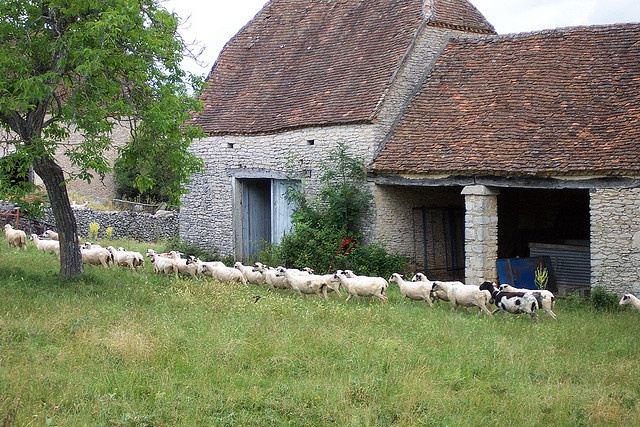Describe the objects in this image and their specific colors. I can see sheep in turquoise, white, gray, olive, and darkgray tones, sheep in turquoise, white, darkgray, tan, and gray tones, sheep in turquoise, black, darkgray, lightgray, and gray tones, sheep in turquoise, white, darkgray, and gray tones, and sheep in turquoise, ivory, darkgray, and gray tones in this image. 